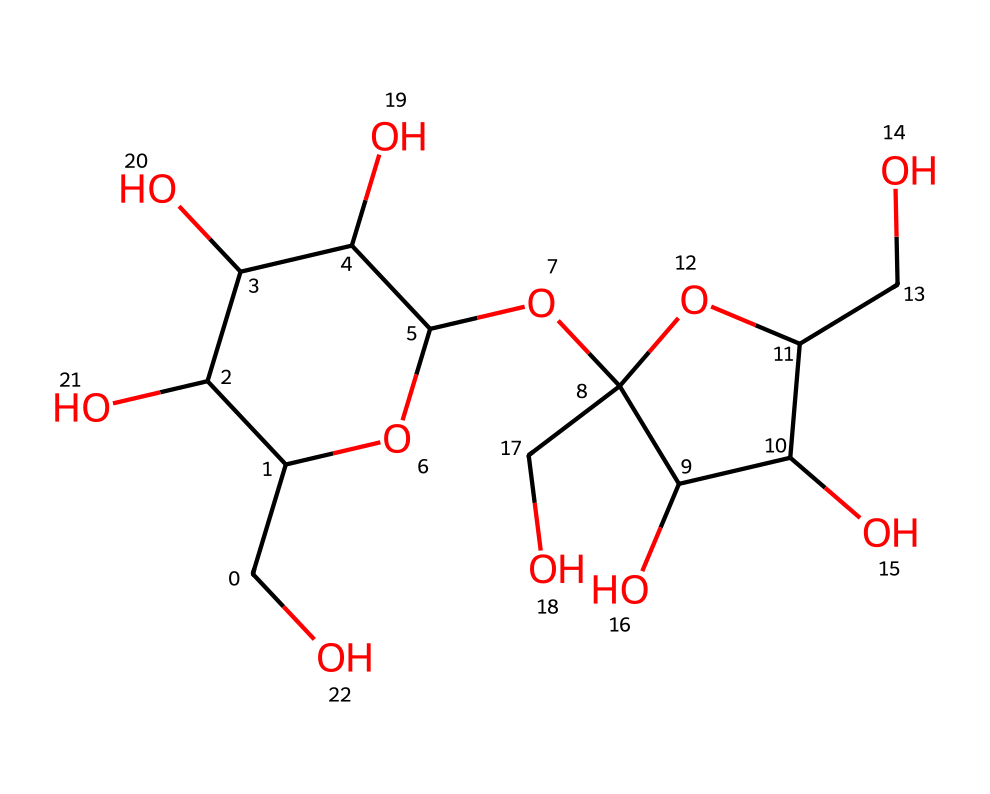What is the name of this chemical? This chemical's structure corresponds to sucrose, which is a common disaccharide found in many plants and is often used as sugar.
Answer: sucrose How many carbon atoms are present? By analyzing the SMILES string, we can count a total of 12 carbon (C) atoms, indicated by the 'C' present and the overall structure.
Answer: 12 What type of carbohydrate is sucrose? Sucrose is categorized as a disaccharide because it is formed from two monosaccharides—glucose and fructose—bonded together.
Answer: disaccharide How many hydroxyl (OH) groups are in sucrose? The structure of sucrose contains 5 hydroxyl (OH) groups, which can be identified by looking for carbon atoms bonded to oxygen atoms with hydrogen atoms.
Answer: 5 What type of bond connects the two monosaccharides in sucrose? The bond that connects glucose and fructose in sucrose is a glycosidic bond, specifically an α-(1→2) bond which is characteristic of disaccharides.
Answer: glycosidic What is the molecular formula of sucrose? The molecular formula is determined by counting each type of atom present in the structure: C12H22O11, representing the total number of carbon, hydrogen, and oxygen atoms in sucrose.
Answer: C12H22O11 